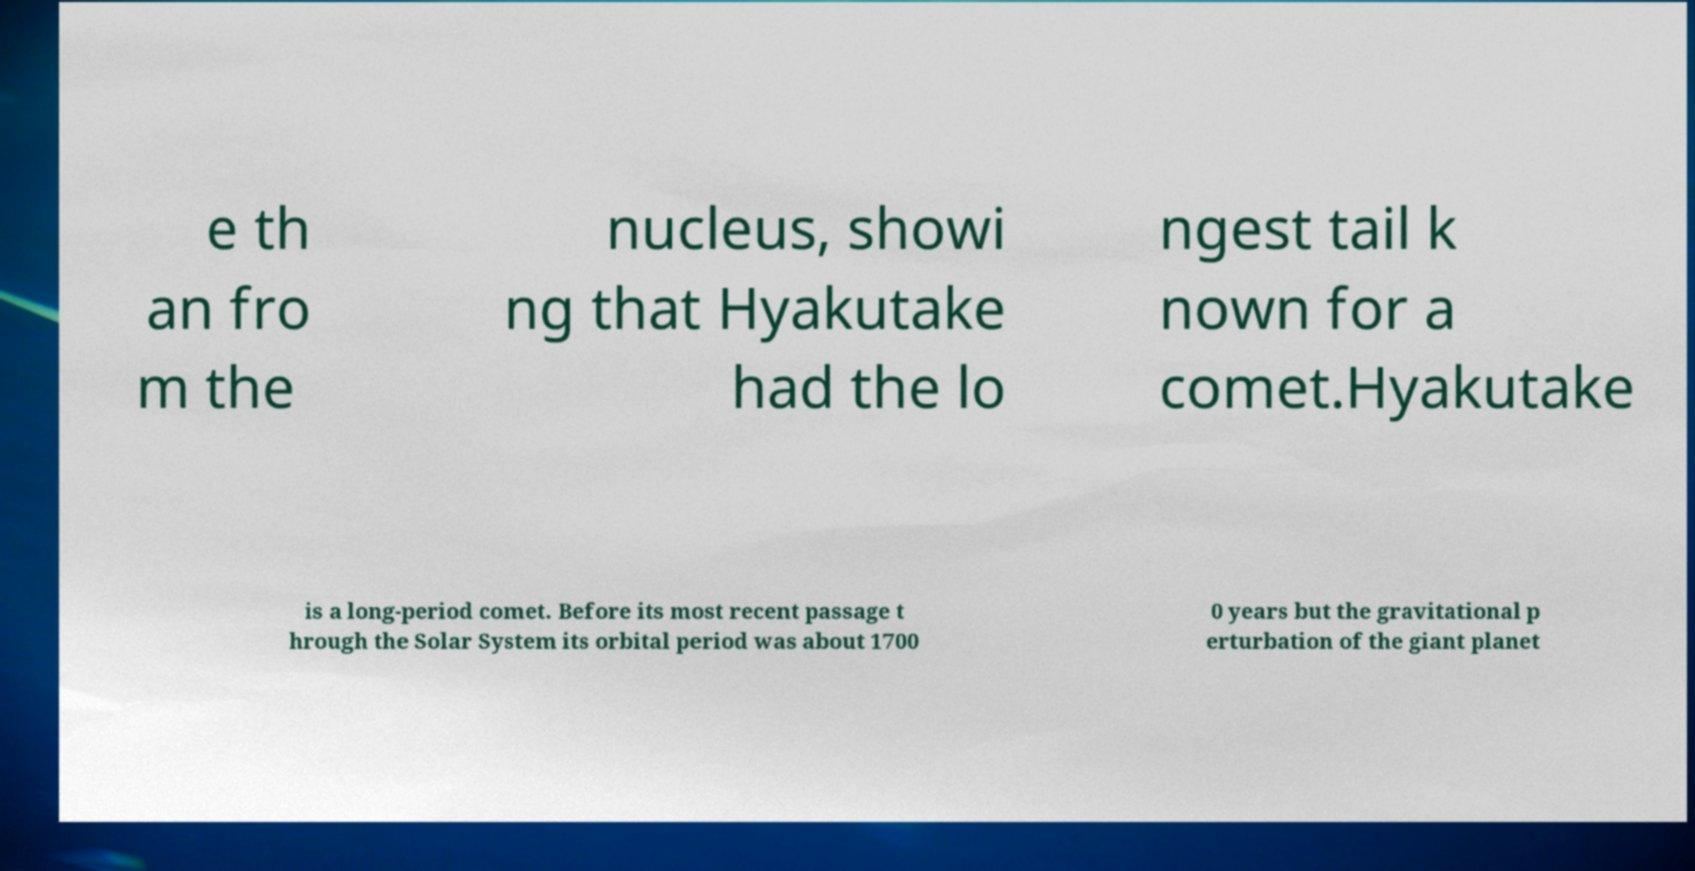Can you read and provide the text displayed in the image?This photo seems to have some interesting text. Can you extract and type it out for me? e th an fro m the nucleus, showi ng that Hyakutake had the lo ngest tail k nown for a comet.Hyakutake is a long-period comet. Before its most recent passage t hrough the Solar System its orbital period was about 1700 0 years but the gravitational p erturbation of the giant planet 